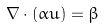Convert formula to latex. <formula><loc_0><loc_0><loc_500><loc_500>\nabla \cdot ( \alpha u ) = \beta</formula> 